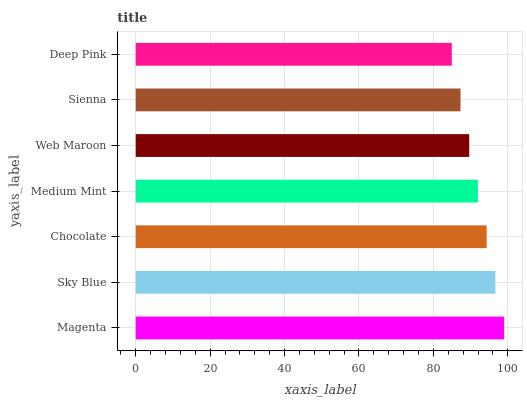Is Deep Pink the minimum?
Answer yes or no. Yes. Is Magenta the maximum?
Answer yes or no. Yes. Is Sky Blue the minimum?
Answer yes or no. No. Is Sky Blue the maximum?
Answer yes or no. No. Is Magenta greater than Sky Blue?
Answer yes or no. Yes. Is Sky Blue less than Magenta?
Answer yes or no. Yes. Is Sky Blue greater than Magenta?
Answer yes or no. No. Is Magenta less than Sky Blue?
Answer yes or no. No. Is Medium Mint the high median?
Answer yes or no. Yes. Is Medium Mint the low median?
Answer yes or no. Yes. Is Chocolate the high median?
Answer yes or no. No. Is Sky Blue the low median?
Answer yes or no. No. 